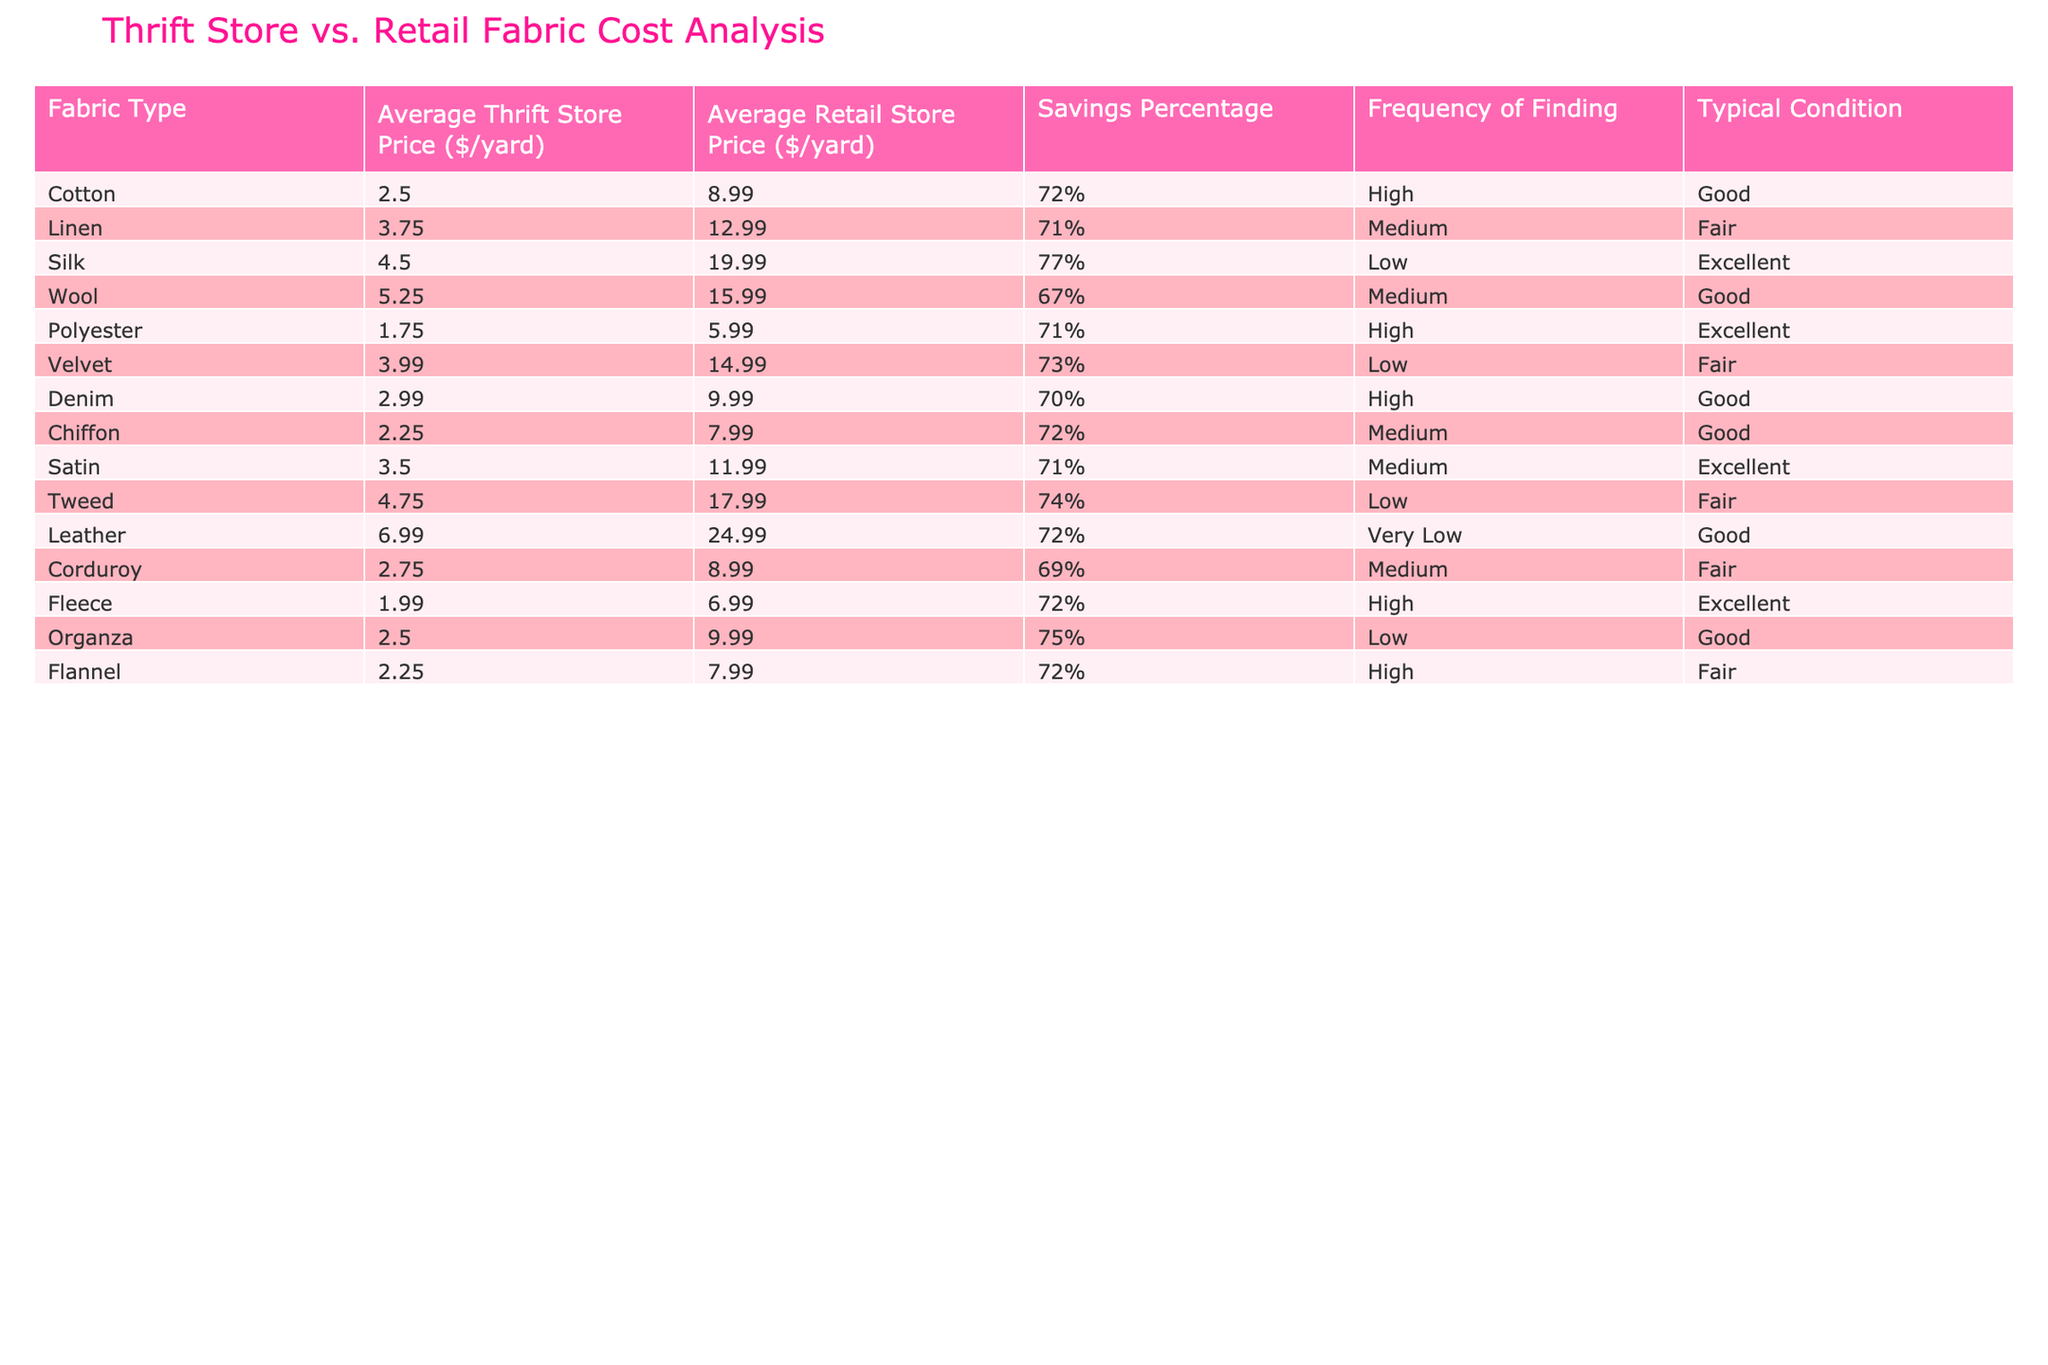What is the average thrift store price for cotton fabric? The table shows that the average thrift store price for cotton fabric is $2.50 per yard.
Answer: $2.50 Which fabric type has the highest savings percentage? The savings percentage for silk is 77%, which is the highest among all the fabric types listed in the table.
Answer: Silk How much more expensive is retail silk fabric compared to thrift store silk fabric? The retail price of silk is $19.99, and the thrift store price is $4.50. The difference is $19.99 - $4.50 = $15.49.
Answer: $15.49 Is the savings percentage for denim fabric higher than that for corduroy fabric? The savings percentage for denim is 70%, while for corduroy it is 69%. Since 70% is greater than 69%, the answer is yes.
Answer: Yes Which fabric has both high frequency of finding and good typical condition? The fabrics that meet these criteria are cotton and polyester, as they both have high frequency of finding and are in good condition according to the table.
Answer: Cotton and Polyester What is the average savings percentage for fabrics that have a medium frequency of finding? The mediums are linen (71%), wool (67%), satin (71%), and flannel (72%). The average savings percentage is (71 + 67 + 71 + 72) / 4 = 70.25%.
Answer: 70.25% Is there any fabric type with a very low frequency of finding? The table indicates that only leather has a very low frequency of finding, confirming the statement as true.
Answer: Yes Calculate the combined savings percentage for wool and velvet fabrics. Wool has a savings percentage of 67% and velvet has 73%. The combined percentage is (67 + 73) = 140%.
Answer: 140% What is the typical condition of chiffon fabric? According to the table, chiffon fabric is in good condition.
Answer: Good Which fabric has the lowest average thrift store price? The average thrift store price for polyester is $1.75/yard, which is the lowest among the listed fabrics.
Answer: $1.75 